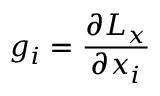<formula> <loc_0><loc_0><loc_500><loc_500>g _ { i } = \frac { \partial L _ { x } } { \partial x _ { i } }</formula> 